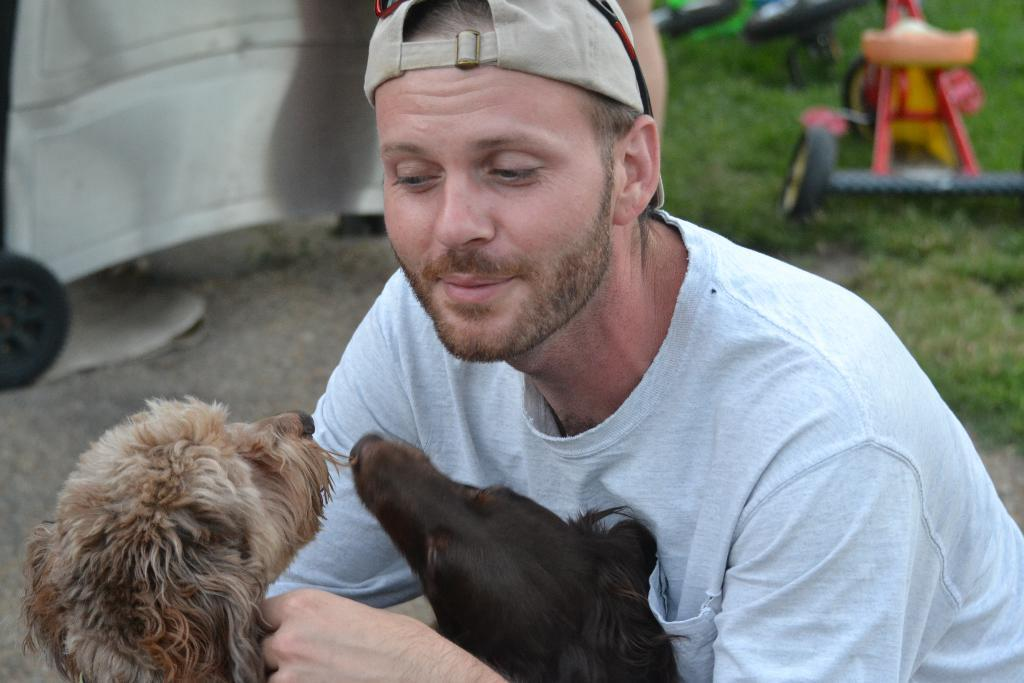Who is present in the image? There is a man in the picture. What is the man wearing? The man is wearing a white T-shirt. What is the man holding in the image? The man is holding two puppies. What can be seen in the background of the image? There is a cycle in the background of the image. What type of band is playing in the background of the image? There is no band present in the image; it features a man holding two puppies and a cycle in the background. How many puppies is the man pulling in the image? The man is not pulling any puppies; he is holding them in his arms. 